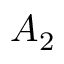Convert formula to latex. <formula><loc_0><loc_0><loc_500><loc_500>A _ { 2 }</formula> 